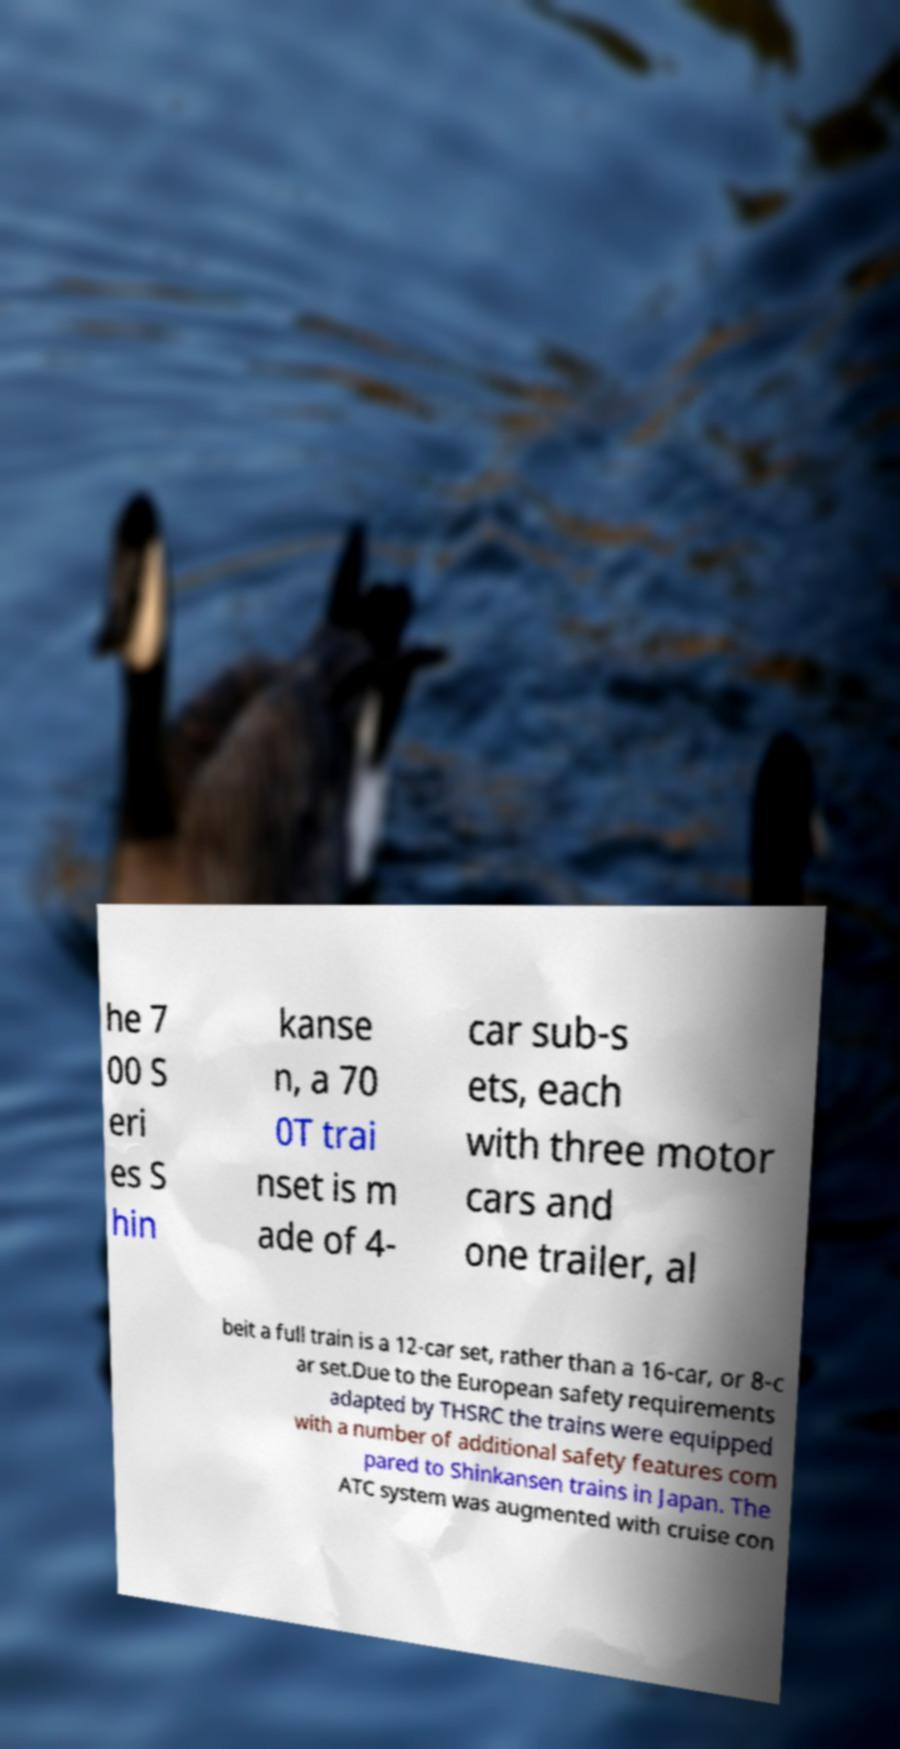What messages or text are displayed in this image? I need them in a readable, typed format. he 7 00 S eri es S hin kanse n, a 70 0T trai nset is m ade of 4- car sub-s ets, each with three motor cars and one trailer, al beit a full train is a 12-car set, rather than a 16-car, or 8-c ar set.Due to the European safety requirements adapted by THSRC the trains were equipped with a number of additional safety features com pared to Shinkansen trains in Japan. The ATC system was augmented with cruise con 